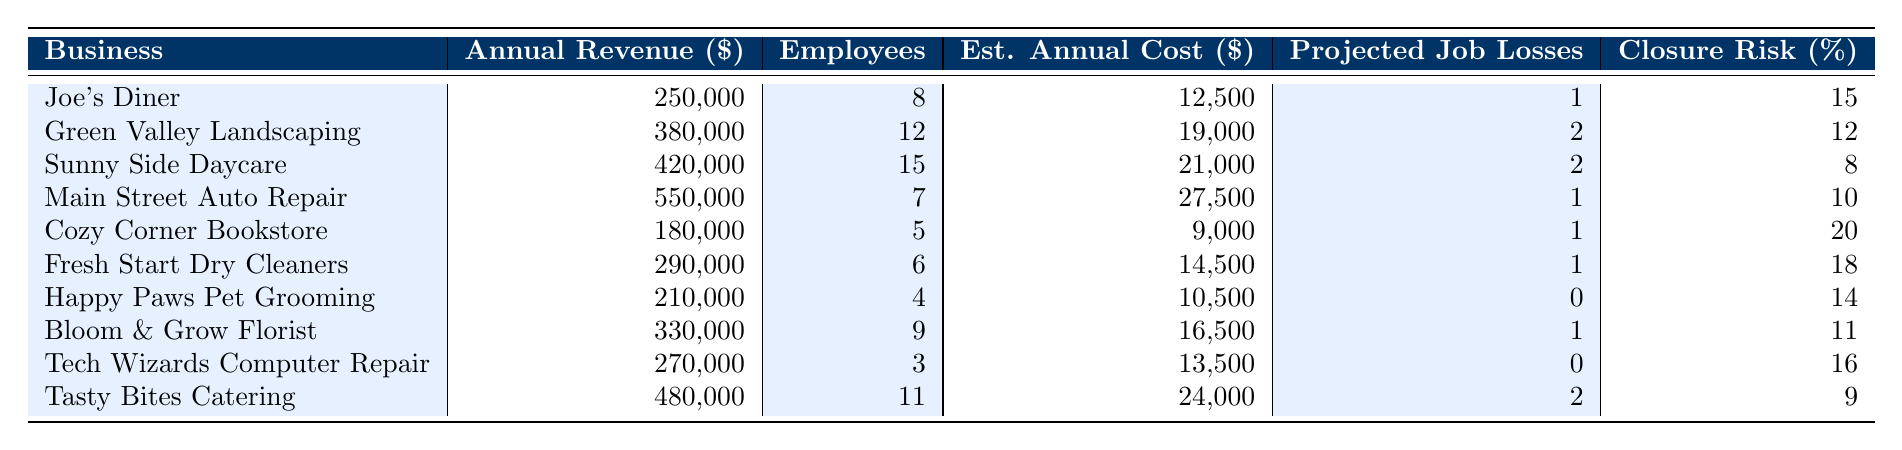What is the annual revenue of Joe's Diner? Referring to the table, Joe's Diner has an annual revenue of $250,000.
Answer: $250,000 How many employees does Fresh Start Dry Cleaners have? The table shows that Fresh Start Dry Cleaners has 6 employees.
Answer: 6 What is the estimated annual cost of new regulations for Tech Wizards Computer Repair? According to the table, the estimated annual cost for Tech Wizards Computer Repair is $13,500.
Answer: $13,500 Which business has the highest projected job losses? Looking at the table, Tasty Bites Catering and Green Valley Landscaping both have the highest projected job losses of 2.
Answer: Tasty Bites Catering and Green Valley Landscaping What is the average estimated annual cost of new regulations for all businesses listed? Adding all estimated annual costs gives $12,500 + $19,000 + $21,000 + $27,500 + $9,000 + $14,500 + $10,500 + $16,500 + $13,500 + $24,000 = $  2, 65,000. Dividing by 10 businesses gives an average of $26,500.
Answer: $26,500 Is there any business listed that has zero projected job losses? Yes, Happy Paws Pet Grooming and Tech Wizards Computer Repair both have zero projected job losses according to the table.
Answer: Yes What percentage closure risk does the Cozy Corner Bookstore face? The table indicates that Cozy Corner Bookstore has a potential business closure risk of 20%.
Answer: 20% Which business has the lowest annual revenue and what is it? The table shows Cozy Corner Bookstore has the lowest annual revenue of $180,000.
Answer: Cozy Corner Bookstore, $180,000 How many total employees are employed at Joe's Diner and Main Street Auto Repair combined? Joe's Diner has 8 employees and Main Street Auto Repair has 7 employees. Adding these gives a total of 15 employees.
Answer: 15 What is the difference in estimated annual costs of new regulations between Sunny Side Daycare and Green Valley Landscaping? Sunny Side Daycare's cost is $21,000 and Green Valley Landscaping's cost is $19,000. The difference is $21,000 - $19,000 = $2,000.
Answer: $2,000 Does the data suggest that businesses with higher annual revenues face higher projected job losses? To analyze this, we see that Tasty Bites Catering has high revenue ($480,000) and two job losses, while Happy Paws Pet Grooming has lower revenue ($210,000) but zero job losses. This indicates no clear correlation based solely on this data.
Answer: No 